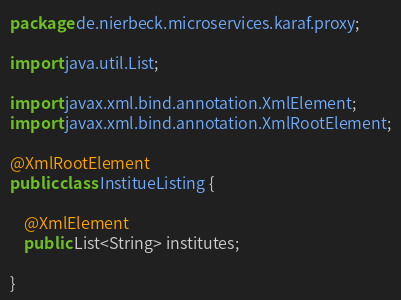Convert code to text. <code><loc_0><loc_0><loc_500><loc_500><_Java_>package de.nierbeck.microservices.karaf.proxy;

import java.util.List;

import javax.xml.bind.annotation.XmlElement;
import javax.xml.bind.annotation.XmlRootElement;

@XmlRootElement
public class InstitueListing {

	@XmlElement
	public List<String> institutes;
	
}
</code> 